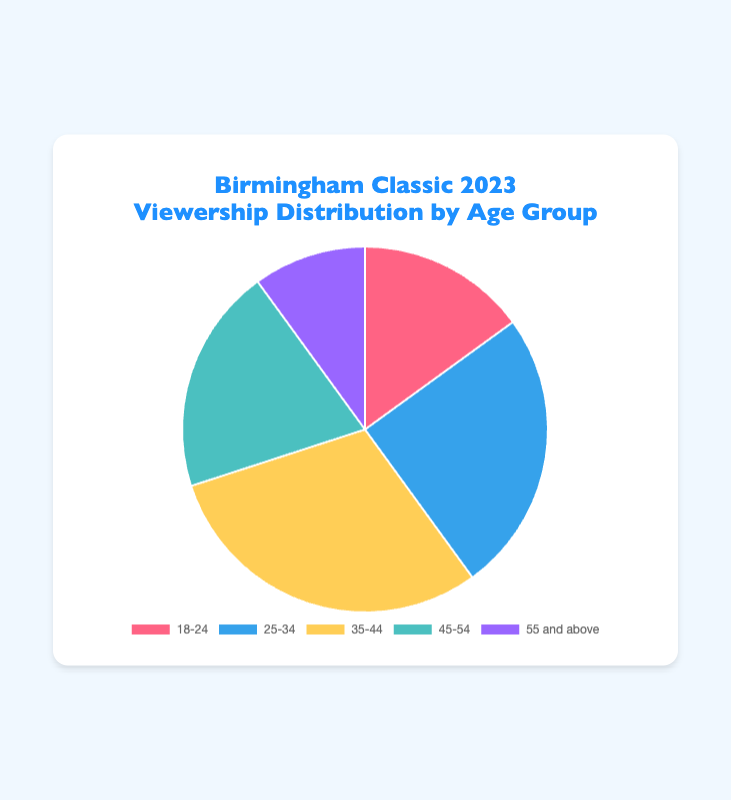Who forms the largest age group in viewership for the Birmingham Classic? The pie chart shows five age groups with their respective percentages. The largest slice indicates the age group '35-44' which has 30%.
Answer: 35-44 What is the total percentage of viewers aged 25-34 and 35-44? Add the percentages of the two age groups: 25-34 (25%) and 35-44 (30%). The sum is 25 + 30 = 55%.
Answer: 55% Which age group has the smallest representation in the viewership? The smallest slice in the pie chart corresponds to the age group '55 and above,' which has 10%.
Answer: 55 and above How much greater is the viewership percentage of the '35-44' age group compared to the '55 and above' age group? Subtract the percentage of '55 and above' (10%) from the '35-44' (30%). The difference is 30% - 10% = 20%.
Answer: 20% What is the combined viewership percentage for age groups above 35? Add the percentages for '35-44' (30%), '45-54' (20%), and '55 and above' (10%). The sum is 30 + 20 + 10 = 60%.
Answer: 60% Which age group is represented by the red slice in the pie chart? The pie chart indicates the color red for the '18-24' age group.
Answer: 18-24 Is the viewership percentage for the '18-24' age group more or less than double the '55 and above' age group? Double the percentage of the '55 and above' group (10%) is 20%. Since '18-24' has 15%, it is less than 20%.
Answer: Less What fraction of the viewers does the '45-54' age group represent? The '45-54' group has 20%. Convert the percentage to a fraction: 20/100 which simplifies to 1/5.
Answer: 1/5 Is the difference between the viewership percentages of the '35-44' and '18-24' age groups using the positive integer? Subtract the percentage of '18-24' (15%) from '35-44' (30%). The difference is 30% - 15% = 15 which is a positive integer.
Answer: Yes 